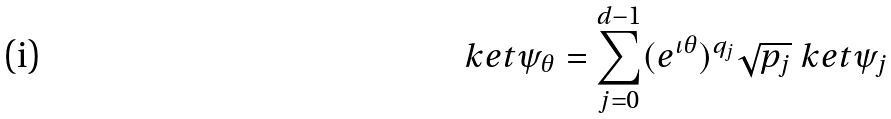<formula> <loc_0><loc_0><loc_500><loc_500>\ k e t { \psi _ { \theta } } = \sum _ { j = 0 } ^ { d - 1 } ( e ^ { \iota \theta } ) ^ { q _ { j } } \sqrt { p _ { j } } \ k e t { \psi _ { j } }</formula> 